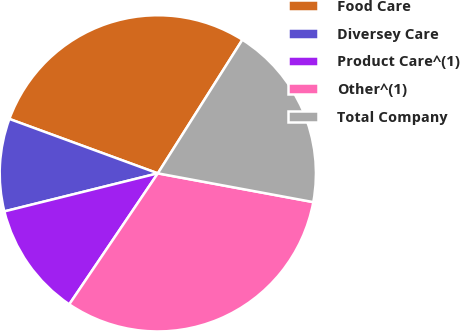Convert chart. <chart><loc_0><loc_0><loc_500><loc_500><pie_chart><fcel>Food Care<fcel>Diversey Care<fcel>Product Care^(1)<fcel>Other^(1)<fcel>Total Company<nl><fcel>28.39%<fcel>9.46%<fcel>11.67%<fcel>31.55%<fcel>18.93%<nl></chart> 